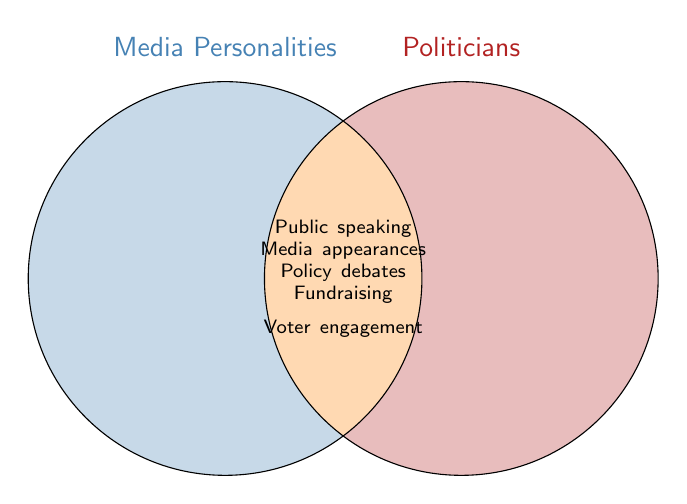Who are the two groups shown in the Venn diagram? The Venn diagram shows two groups: Media Personalities and Politicians, each represented by a distinct circle.
Answer: Media Personalities and Politicians What is the shared area between the two circles representing? The shared area between the two circles represents the common interests of both media personalities and politicians.
Answer: Common interests Name one common interest shared by both media personalities and politicians. One common interest shared by both groups is public speaking.
Answer: Public speaking How many shared interests are highlighted in the Venn diagram? The diagram highlights five shared interests: public speaking, media appearances, policy debates, fundraising, and voter engagement.
Answer: Five Do media personalities and politicians share fundraising as an interest? Yes, both media personalities and politicians share fundraising as an interest, as indicated in the overlap of the circles.
Answer: Yes Which color represents the interest area of media personalities only? The interest area of media personalities is represented by a blue shade in the Venn diagram.
Answer: Blue Which color represents the interest area of politicians only? The interest area of politicians is represented by a red shade in the Venn diagram.
Answer: Red Are policy debates an interest exclusive to either media personalities or politicians? No, policy debates are listed as a shared interest between both media personalities and politicians.
Answer: No 